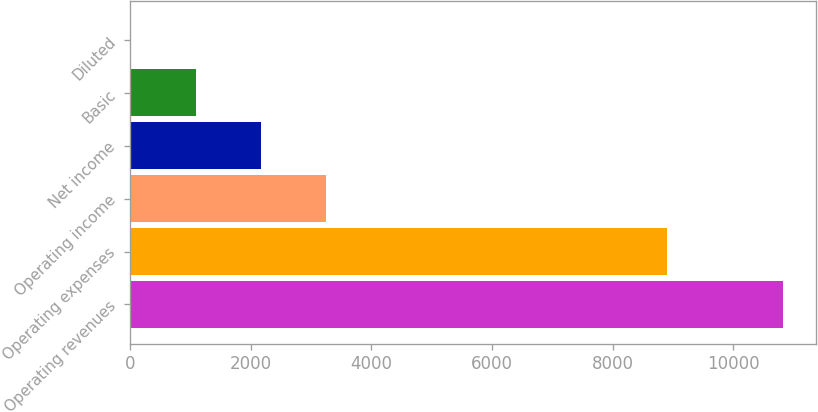<chart> <loc_0><loc_0><loc_500><loc_500><bar_chart><fcel>Operating revenues<fcel>Operating expenses<fcel>Operating income<fcel>Net income<fcel>Basic<fcel>Diluted<nl><fcel>10827<fcel>8906<fcel>3249.79<fcel>2167.33<fcel>1084.87<fcel>2.41<nl></chart> 